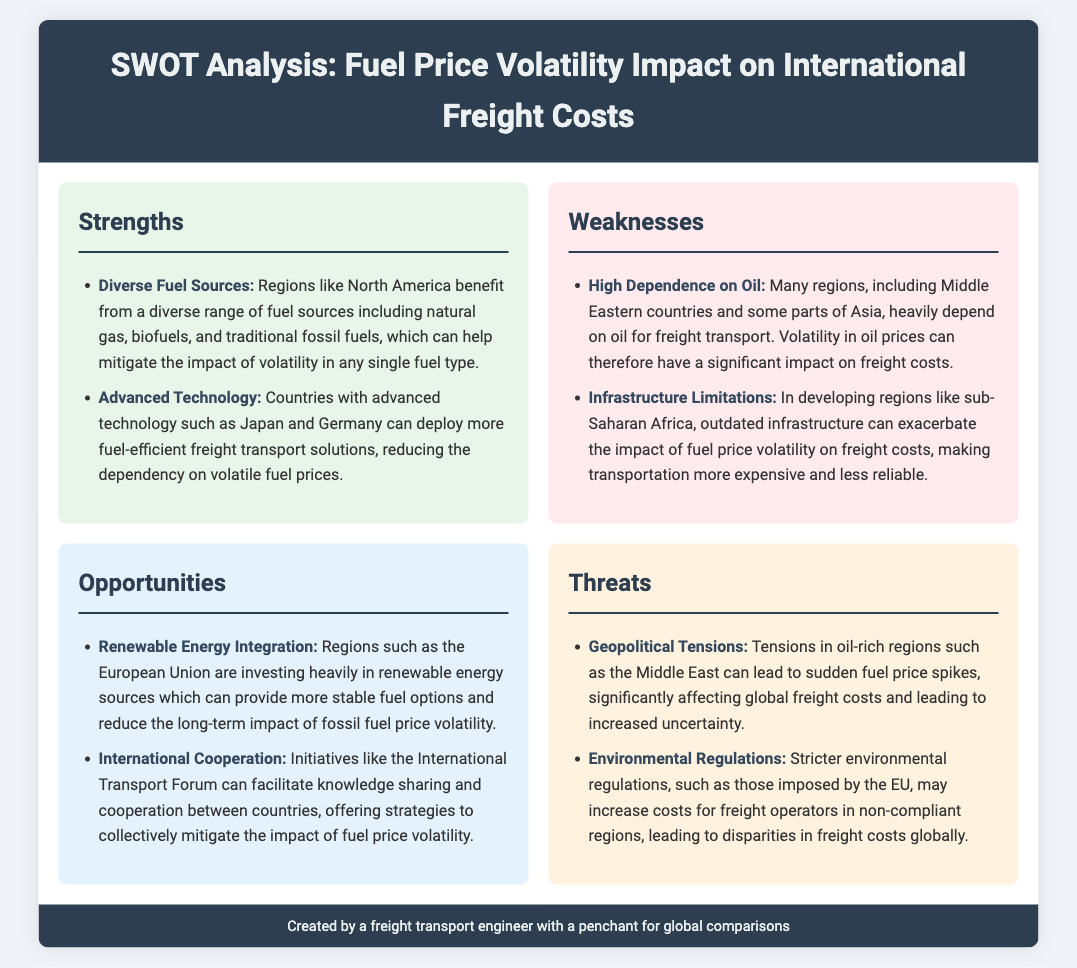What is a strength related to fuel sources? The document states that regions like North America benefit from a diverse range of fuel sources, which mitigates volatility.
Answer: Diverse Fuel Sources Which region heavily depends on oil for freight transport? The document mentions that many regions, including Middle Eastern countries, have a high dependence on oil.
Answer: Middle Eastern countries What opportunity is highlighted for the European Union? The document indicates that the European Union is investing in renewable energy sources for stable fuel options.
Answer: Renewable Energy Integration What is a threat caused by geopolitical factors? The document notes that tensions in oil-rich regions can lead to sudden fuel price spikes.
Answer: Geopolitical Tensions Which country is mentioned as having advanced technology in freight transport? The document highlights countries with advanced technology, specifying Japan and Germany as examples.
Answer: Japan and Germany What kind of regulation might increase costs for freight operators? The document states that stricter environmental regulations may increase costs for non-compliant regions.
Answer: Environmental Regulations What is one weakness of developing regions regarding infrastructure? The document points out that outdated infrastructure in regions like sub-Saharan Africa can exacerbate fuel price volatility.
Answer: Infrastructure Limitations How can international cooperation help address fuel price volatility? The document mentions initiatives like the International Transport Forum can facilitate knowledge sharing and cooperation among countries.
Answer: International Cooperation 